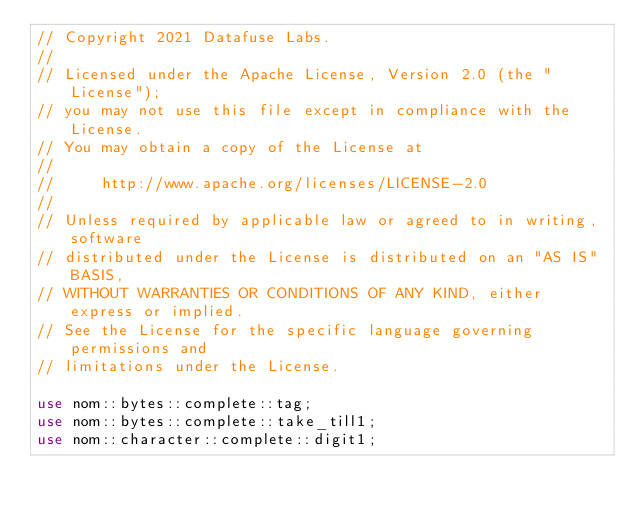Convert code to text. <code><loc_0><loc_0><loc_500><loc_500><_Rust_>// Copyright 2021 Datafuse Labs.
//
// Licensed under the Apache License, Version 2.0 (the "License");
// you may not use this file except in compliance with the License.
// You may obtain a copy of the License at
//
//     http://www.apache.org/licenses/LICENSE-2.0
//
// Unless required by applicable law or agreed to in writing, software
// distributed under the License is distributed on an "AS IS" BASIS,
// WITHOUT WARRANTIES OR CONDITIONS OF ANY KIND, either express or implied.
// See the License for the specific language governing permissions and
// limitations under the License.

use nom::bytes::complete::tag;
use nom::bytes::complete::take_till1;
use nom::character::complete::digit1;</code> 